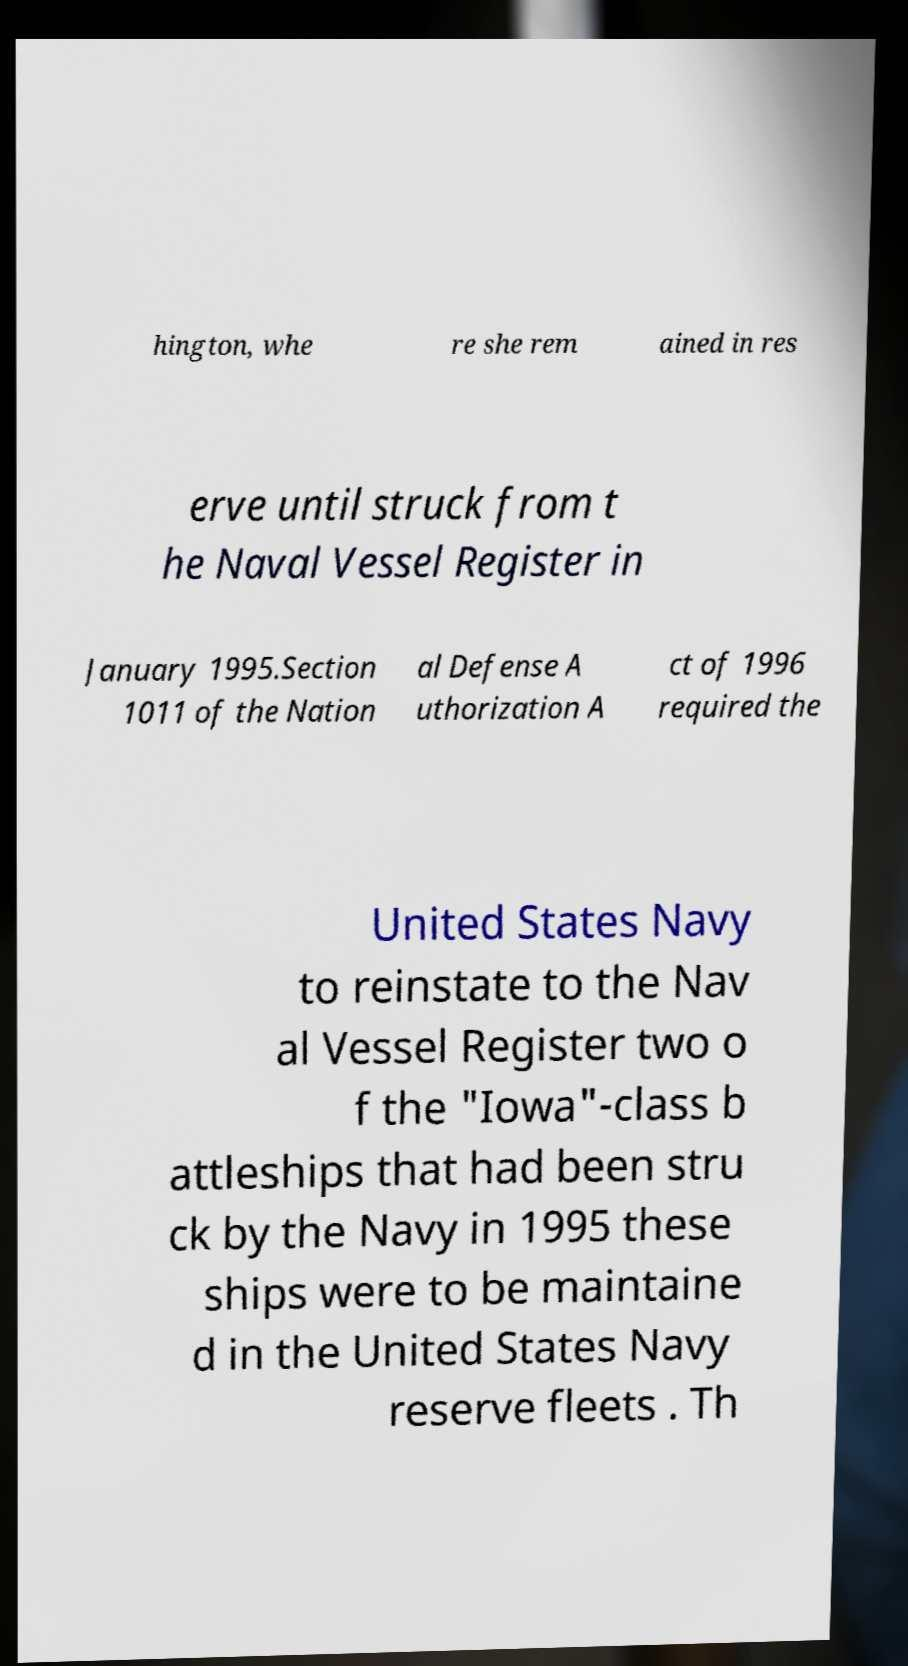Please read and relay the text visible in this image. What does it say? hington, whe re she rem ained in res erve until struck from t he Naval Vessel Register in January 1995.Section 1011 of the Nation al Defense A uthorization A ct of 1996 required the United States Navy to reinstate to the Nav al Vessel Register two o f the "Iowa"-class b attleships that had been stru ck by the Navy in 1995 these ships were to be maintaine d in the United States Navy reserve fleets . Th 